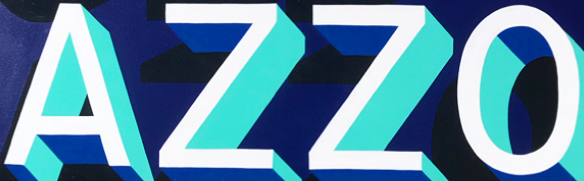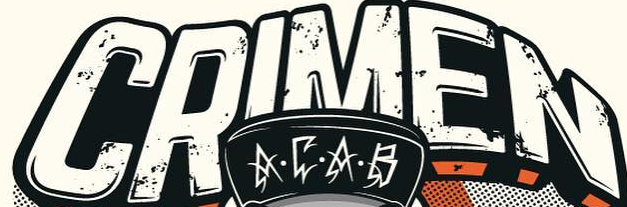What words can you see in these images in sequence, separated by a semicolon? AZZO; CRIMEN 